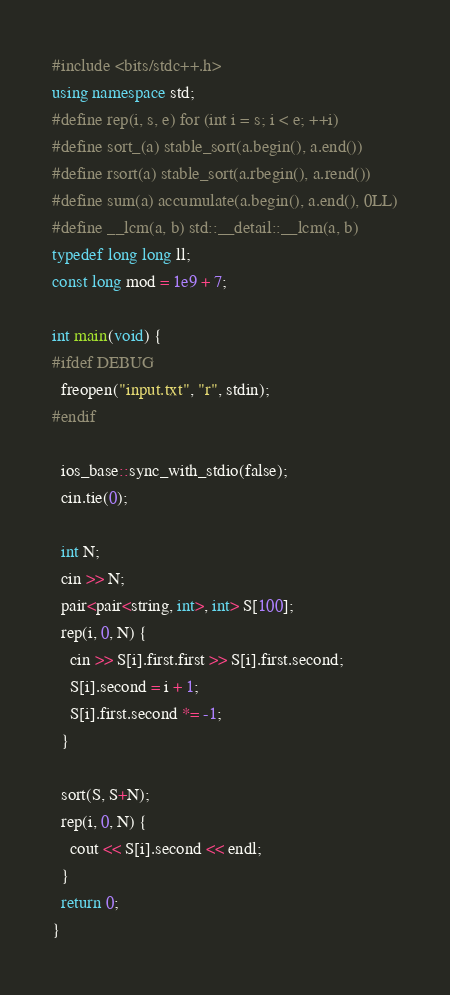<code> <loc_0><loc_0><loc_500><loc_500><_C++_>#include <bits/stdc++.h>
using namespace std;
#define rep(i, s, e) for (int i = s; i < e; ++i)
#define sort_(a) stable_sort(a.begin(), a.end())
#define rsort(a) stable_sort(a.rbegin(), a.rend())
#define sum(a) accumulate(a.begin(), a.end(), 0LL)
#define __lcm(a, b) std::__detail::__lcm(a, b)
typedef long long ll;
const long mod = 1e9 + 7;

int main(void) {
#ifdef DEBUG
  freopen("input.txt", "r", stdin);
#endif

  ios_base::sync_with_stdio(false);
  cin.tie(0);

  int N;
  cin >> N;
  pair<pair<string, int>, int> S[100];
  rep(i, 0, N) {
    cin >> S[i].first.first >> S[i].first.second;
    S[i].second = i + 1;
    S[i].first.second *= -1;
  }

  sort(S, S+N);
  rep(i, 0, N) {
    cout << S[i].second << endl;
  }
  return 0;
}
</code> 